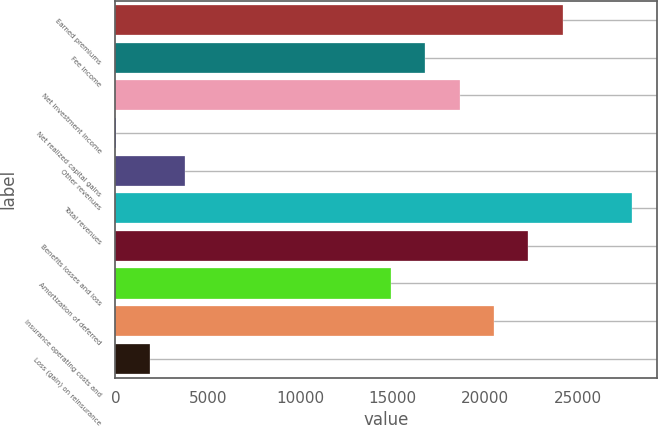Convert chart to OTSL. <chart><loc_0><loc_0><loc_500><loc_500><bar_chart><fcel>Earned premiums<fcel>Fee income<fcel>Net investment income<fcel>Net realized capital gains<fcel>Other revenues<fcel>Total revenues<fcel>Benefits losses and loss<fcel>Amortization of deferred<fcel>Insurance operating costs and<fcel>Loss (gain) on reinsurance<nl><fcel>24193.4<fcel>16754.2<fcel>18614<fcel>16<fcel>3735.6<fcel>27913<fcel>22333.6<fcel>14894.4<fcel>20473.8<fcel>1875.8<nl></chart> 